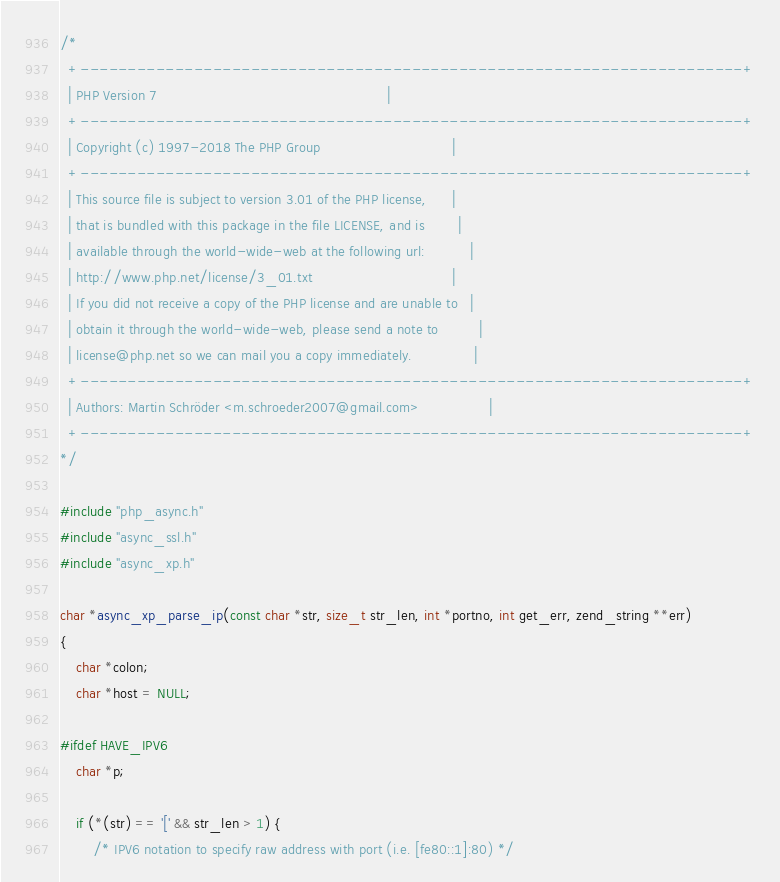Convert code to text. <code><loc_0><loc_0><loc_500><loc_500><_C_>/*
  +----------------------------------------------------------------------+
  | PHP Version 7                                                        |
  +----------------------------------------------------------------------+
  | Copyright (c) 1997-2018 The PHP Group                                |
  +----------------------------------------------------------------------+
  | This source file is subject to version 3.01 of the PHP license,      |
  | that is bundled with this package in the file LICENSE, and is        |
  | available through the world-wide-web at the following url:           |
  | http://www.php.net/license/3_01.txt                                  |
  | If you did not receive a copy of the PHP license and are unable to   |
  | obtain it through the world-wide-web, please send a note to          |
  | license@php.net so we can mail you a copy immediately.               |
  +----------------------------------------------------------------------+
  | Authors: Martin Schröder <m.schroeder2007@gmail.com>                 |
  +----------------------------------------------------------------------+
*/

#include "php_async.h"
#include "async_ssl.h"
#include "async_xp.h"

char *async_xp_parse_ip(const char *str, size_t str_len, int *portno, int get_err, zend_string **err)
{
    char *colon;
    char *host = NULL;

#ifdef HAVE_IPV6
    char *p;

    if (*(str) == '[' && str_len > 1) {
        /* IPV6 notation to specify raw address with port (i.e. [fe80::1]:80) */</code> 